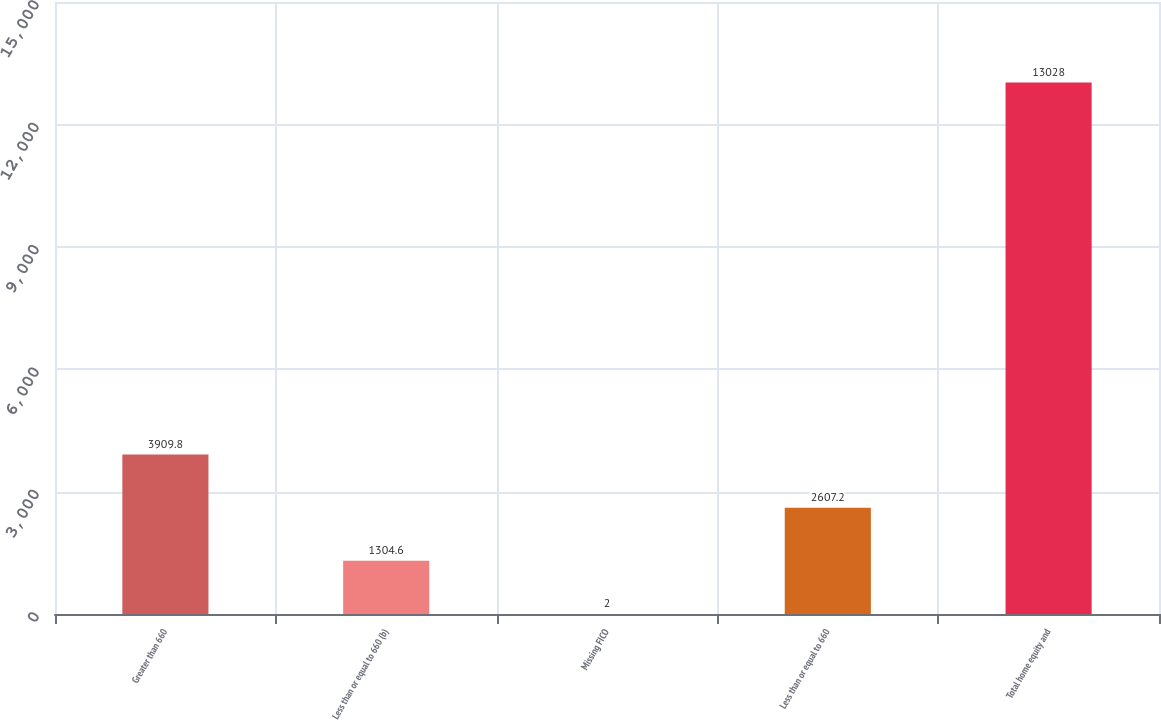Convert chart. <chart><loc_0><loc_0><loc_500><loc_500><bar_chart><fcel>Greater than 660<fcel>Less than or equal to 660 (b)<fcel>Missing FICO<fcel>Less than or equal to 660<fcel>Total home equity and<nl><fcel>3909.8<fcel>1304.6<fcel>2<fcel>2607.2<fcel>13028<nl></chart> 